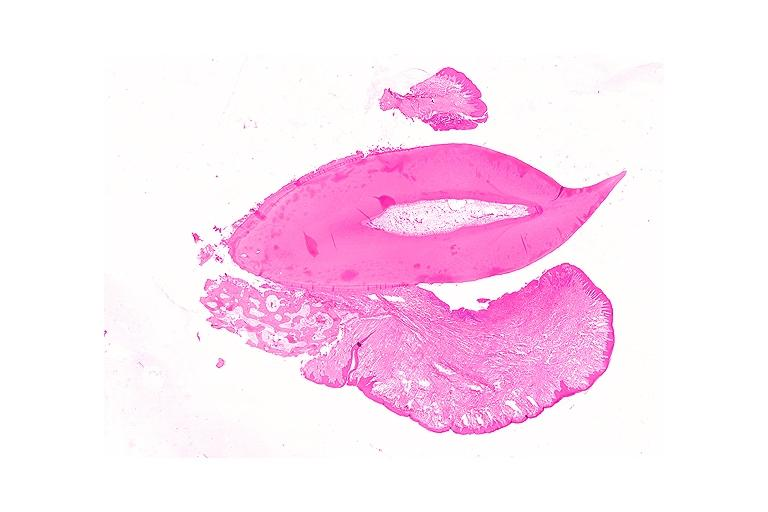what does this image show?
Answer the question using a single word or phrase. Periodontal fibroma 